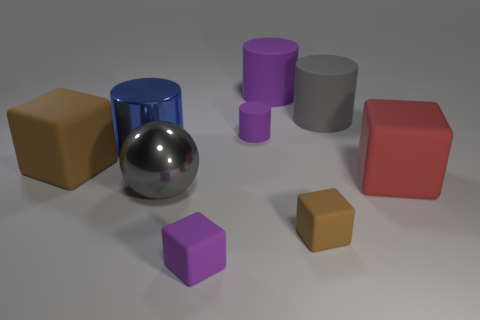Is the color of the large cylinder right of the large purple cylinder the same as the metal sphere?
Offer a terse response. Yes. What shape is the large gray thing on the left side of the small purple object that is behind the gray thing that is in front of the blue object?
Provide a short and direct response. Sphere. There is a large thing that is the same color as the tiny rubber cylinder; what material is it?
Offer a terse response. Rubber. What number of big gray things have the same shape as the big purple object?
Give a very brief answer. 1. There is a large cube that is on the left side of the big blue cylinder; does it have the same color as the large block in front of the large brown thing?
Ensure brevity in your answer.  No. There is a purple cylinder that is the same size as the blue metallic cylinder; what material is it?
Ensure brevity in your answer.  Rubber. Is there a shiny object that has the same size as the metal cylinder?
Your response must be concise. Yes. Are there fewer large gray rubber cylinders in front of the big gray sphere than brown blocks?
Offer a very short reply. Yes. Is the number of big gray rubber objects on the right side of the large metal ball less than the number of brown cubes that are on the right side of the blue cylinder?
Your answer should be compact. No. What number of cylinders are big metal things or tiny purple rubber objects?
Offer a very short reply. 2. 